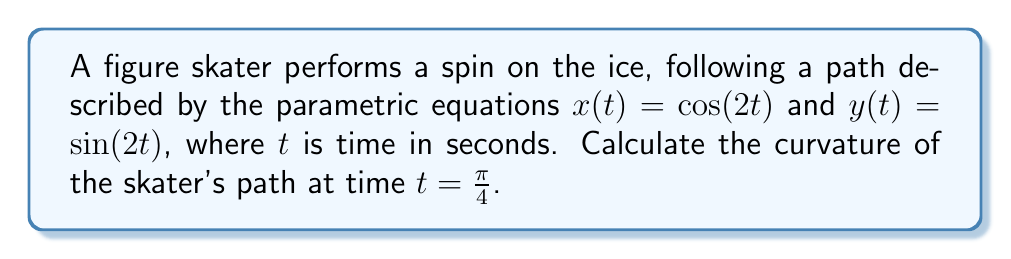Can you answer this question? To find the curvature of the skater's path, we'll follow these steps:

1) The formula for curvature $\kappa$ of a parametric curve is:

   $$\kappa = \frac{|x'y'' - y'x''|}{(x'^2 + y'^2)^{3/2}}$$

2) Let's calculate the first and second derivatives:
   
   $x' = -2\sin(2t)$, $y' = 2\cos(2t)$
   $x'' = -4\cos(2t)$, $y'' = -4\sin(2t)$

3) Now, let's substitute these into our curvature formula:

   $$\kappa = \frac{|(-2\sin(2t))(-4\sin(2t)) - (2\cos(2t))(-4\cos(2t))|}{((-2\sin(2t))^2 + (2\cos(2t))^2)^{3/2}}$$

4) Simplify the numerator:

   $$\kappa = \frac{|8\sin^2(2t) + 8\cos^2(2t)|}{(4\sin^2(2t) + 4\cos^2(2t))^{3/2}}$$

5) Use the identity $\sin^2(2t) + \cos^2(2t) = 1$:

   $$\kappa = \frac{8}{(4)^{3/2}} = \frac{8}{8} = 1$$

6) This result is constant, meaning the curvature is the same at all points on the path, including at $t = \frac{\pi}{4}$.
Answer: $1$ 